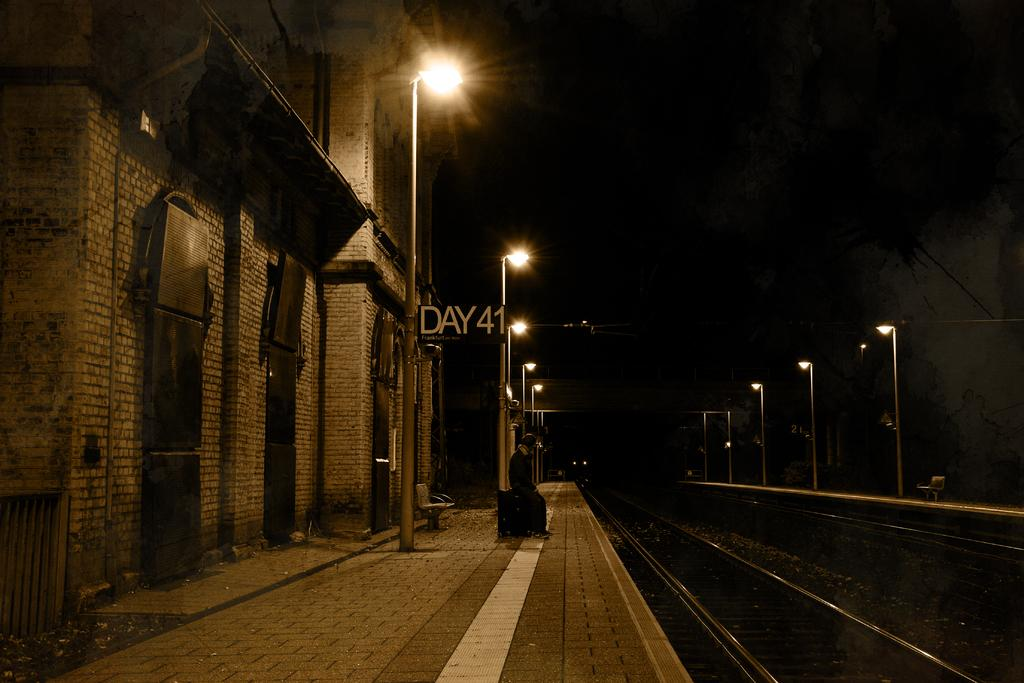<image>
Share a concise interpretation of the image provided. The sign at the train tracks says Day 41. 